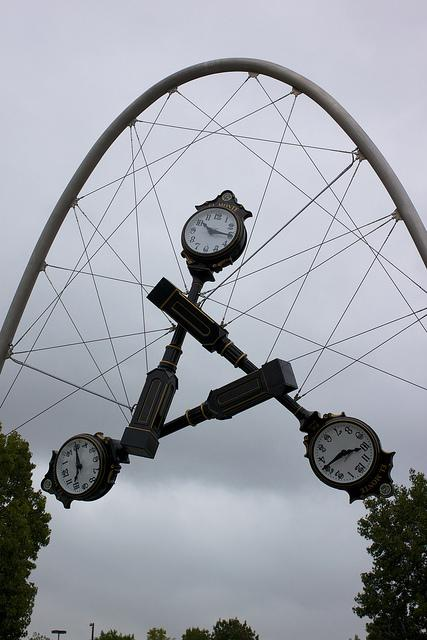Why are the clocks all facing different directions? art 